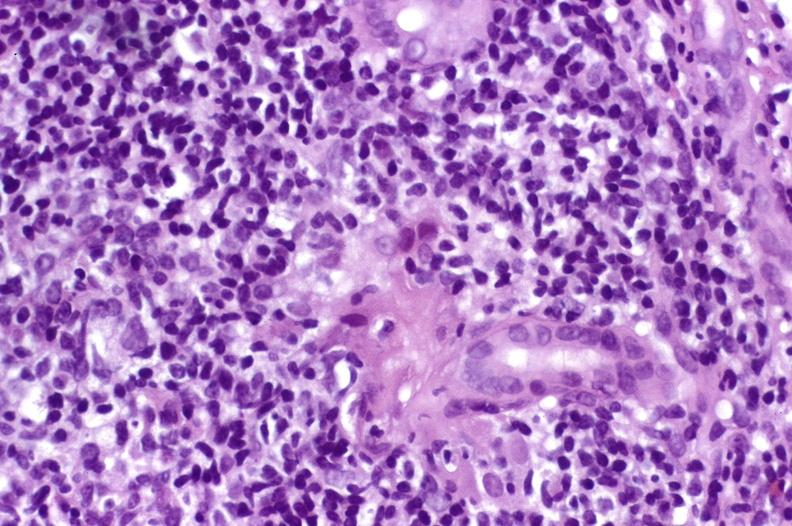s monoclonal gammopathy present?
Answer the question using a single word or phrase. No 